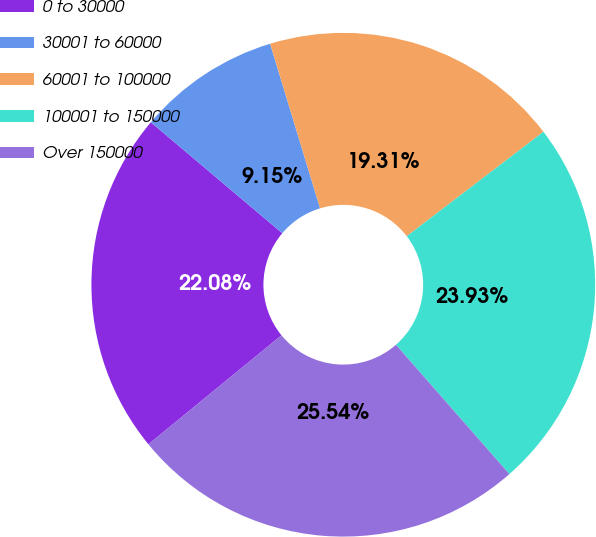Convert chart to OTSL. <chart><loc_0><loc_0><loc_500><loc_500><pie_chart><fcel>0 to 30000<fcel>30001 to 60000<fcel>60001 to 100000<fcel>100001 to 150000<fcel>Over 150000<nl><fcel>22.08%<fcel>9.15%<fcel>19.31%<fcel>23.93%<fcel>25.54%<nl></chart> 